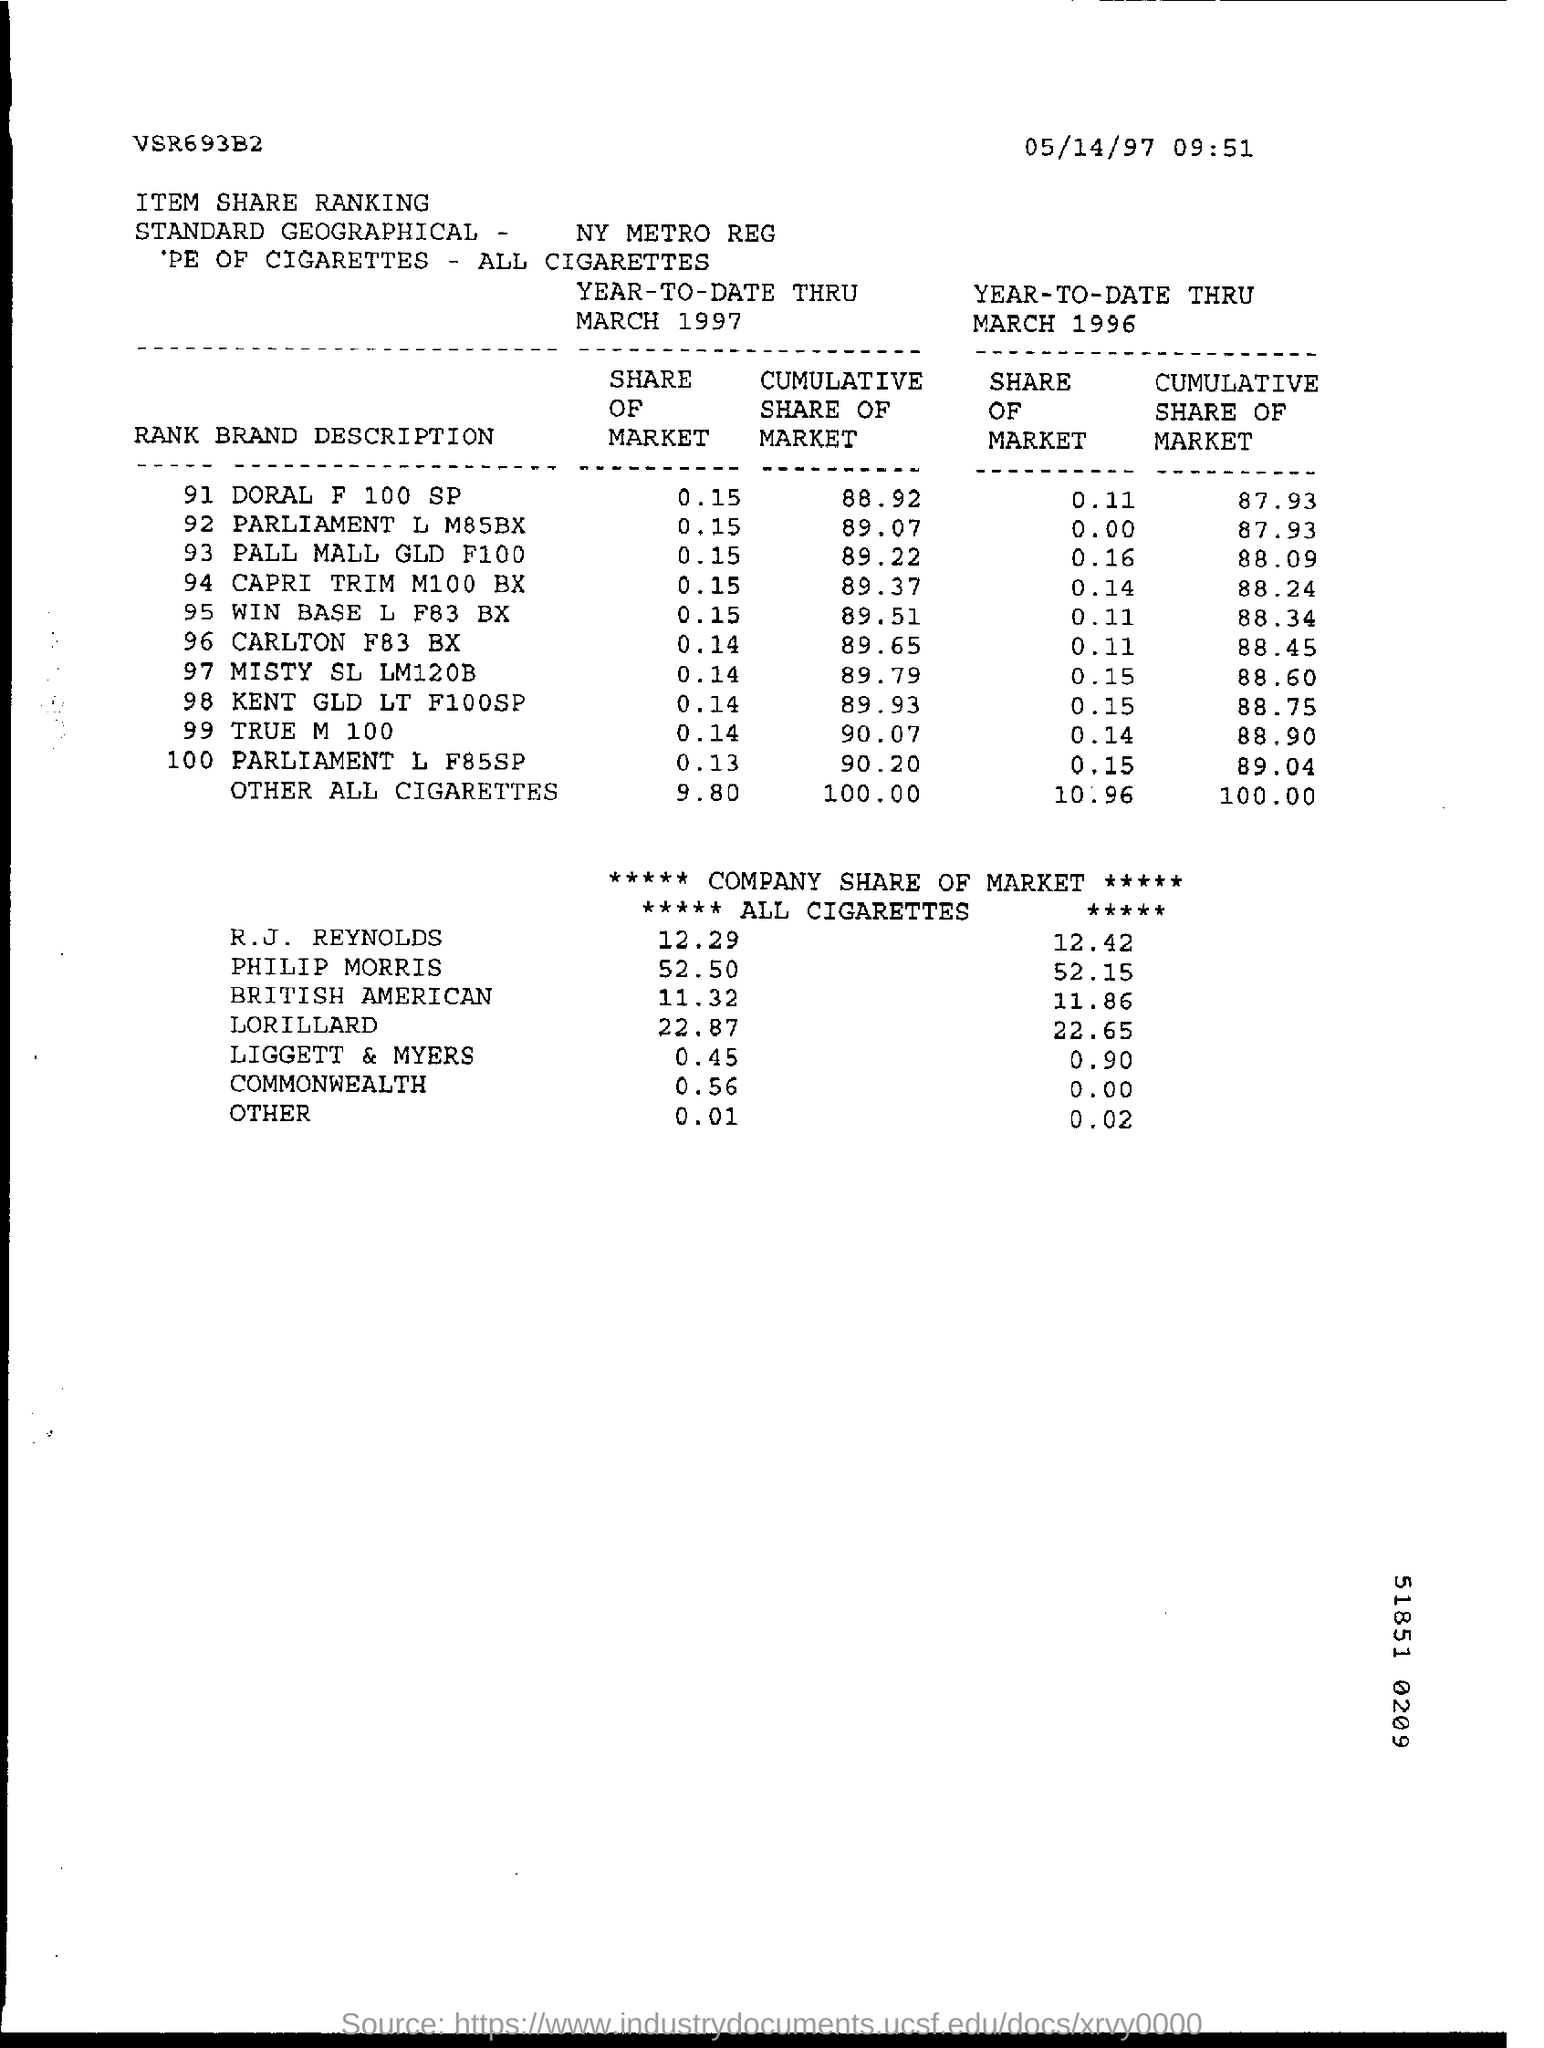Draw attention to some important aspects in this diagram. Commonwealth Bank, which had no market shares in the year 1996, is a notable exception. In the year 1997, Liggett & Myers had the lowest market share among all companies. In the year 1996, it was Philip Morris that held the greater share of the market. In 1997, the market share value of Phillip Morris was 52.50%. 